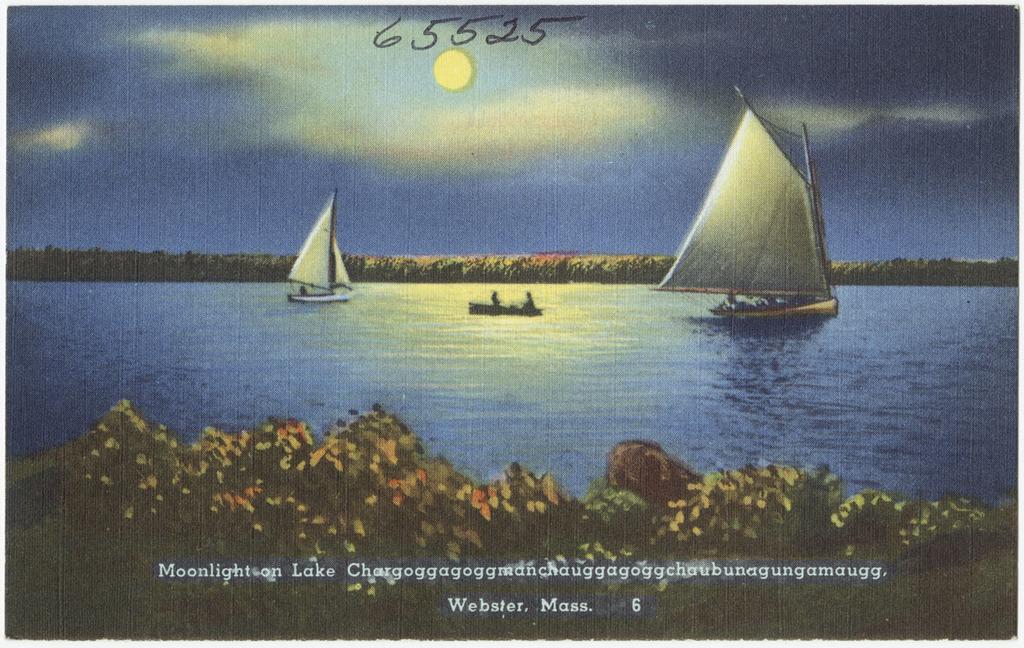How would you summarize this image in a sentence or two? In this picture we can see some plants in the front, there is some text at the bottom, we can see water and boats in the middle, there are some numbers and the sky at the top of the picture. 